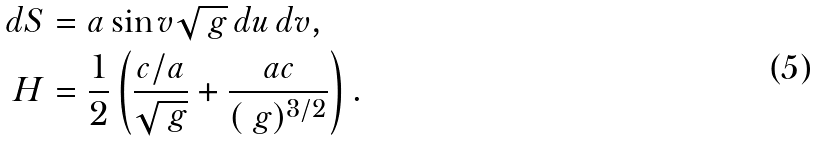<formula> <loc_0><loc_0><loc_500><loc_500>d S & = a \sin v \sqrt { \ g } \, d u \, d v , \\ H & = \frac { 1 } { 2 } \left ( \frac { c / a } { \sqrt { \ g } } + \frac { a c } { ( \ g ) ^ { 3 / 2 } } \right ) .</formula> 